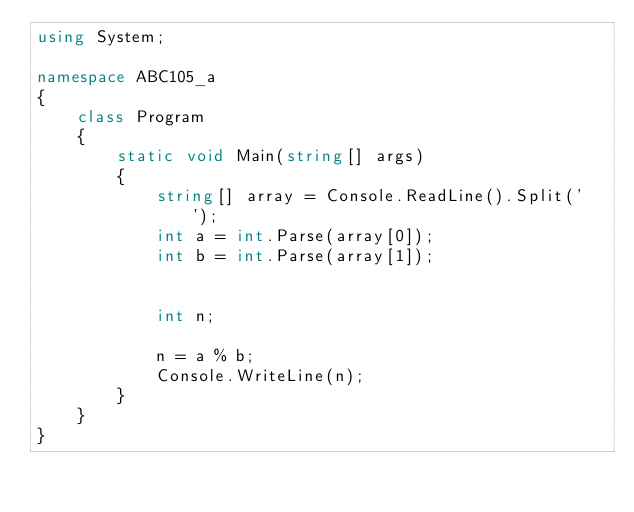Convert code to text. <code><loc_0><loc_0><loc_500><loc_500><_C#_>using System;

namespace ABC105_a
{
    class Program
    {
        static void Main(string[] args)
        {
            string[] array = Console.ReadLine().Split(' ');
            int a = int.Parse(array[0]);
            int b = int.Parse(array[1]);
           
            
            int n;
           
            n = a % b;
            Console.WriteLine(n);
        }
    }
}
</code> 